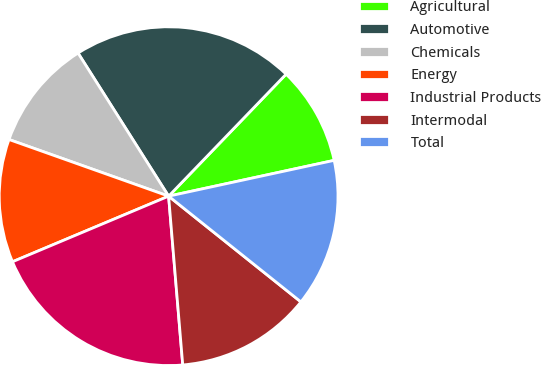<chart> <loc_0><loc_0><loc_500><loc_500><pie_chart><fcel>Agricultural<fcel>Automotive<fcel>Chemicals<fcel>Energy<fcel>Industrial Products<fcel>Intermodal<fcel>Total<nl><fcel>9.41%<fcel>21.18%<fcel>10.59%<fcel>11.76%<fcel>20.0%<fcel>12.94%<fcel>14.12%<nl></chart> 